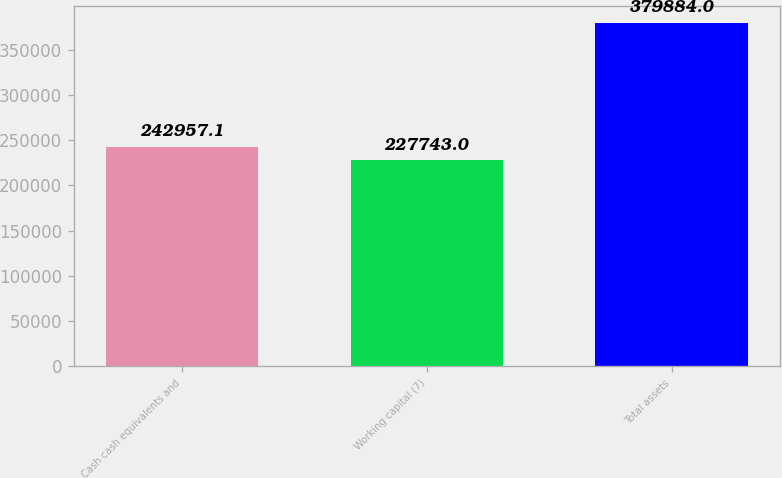Convert chart to OTSL. <chart><loc_0><loc_0><loc_500><loc_500><bar_chart><fcel>Cash cash equivalents and<fcel>Working capital (7)<fcel>Total assets<nl><fcel>242957<fcel>227743<fcel>379884<nl></chart> 